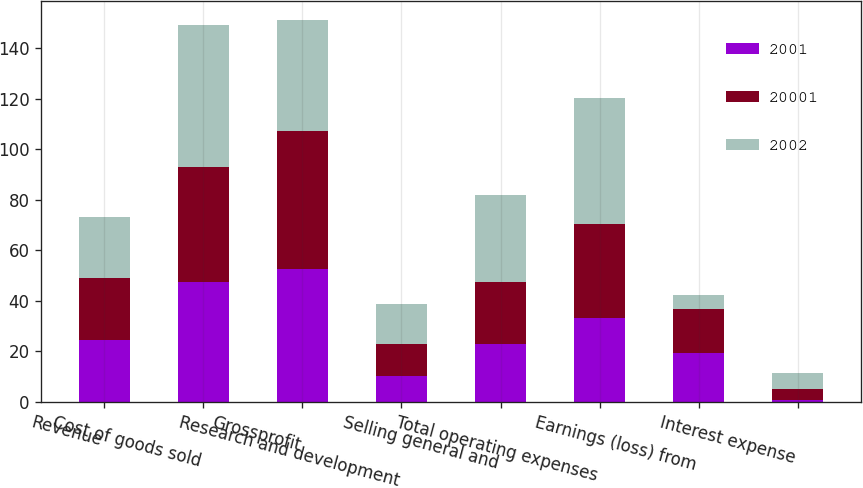Convert chart to OTSL. <chart><loc_0><loc_0><loc_500><loc_500><stacked_bar_chart><ecel><fcel>Revenue<fcel>Cost of goods sold<fcel>Grossprofit<fcel>Research and development<fcel>Selling general and<fcel>Total operating expenses<fcel>Earnings (loss) from<fcel>Interest expense<nl><fcel>2001<fcel>24.4<fcel>47.5<fcel>52.5<fcel>10.3<fcel>23<fcel>33.3<fcel>19.2<fcel>0.6<nl><fcel>20001<fcel>24.4<fcel>45.5<fcel>54.5<fcel>12.7<fcel>24.4<fcel>37.1<fcel>17.4<fcel>4.4<nl><fcel>2002<fcel>24.4<fcel>55.9<fcel>44.1<fcel>15.6<fcel>34.3<fcel>49.9<fcel>5.8<fcel>6.5<nl></chart> 